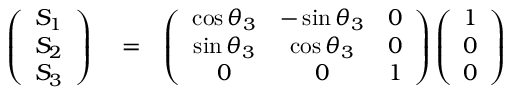Convert formula to latex. <formula><loc_0><loc_0><loc_500><loc_500>\begin{array} { r l r } { \left ( \begin{array} { c } { S _ { 1 } } \\ { S _ { 2 } } \\ { S _ { 3 } } \end{array} \right ) } & = } & { \left ( \begin{array} { c c c } { \cos \theta _ { 3 } } & { - \sin \theta _ { 3 } } & { 0 } \\ { \sin \theta _ { 3 } } & { \cos \theta _ { 3 } } & { 0 } \\ { 0 } & { 0 } & { 1 } \end{array} \right ) \left ( \begin{array} { c } { 1 } \\ { 0 } \\ { 0 } \end{array} \right ) } \end{array}</formula> 